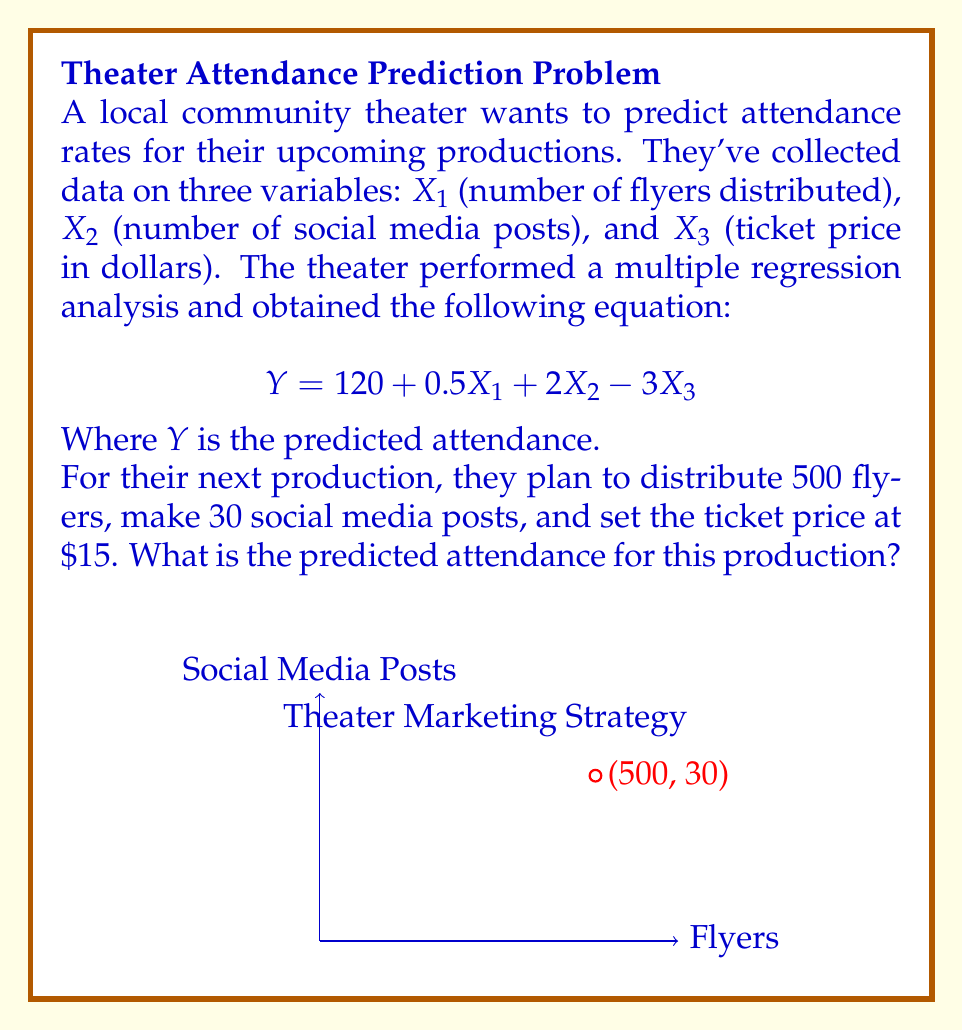Provide a solution to this math problem. To solve this problem, we'll use the multiple regression equation provided and substitute the given values for X₁, X₂, and X₃.

The equation is:
$$Y = 120 + 0.5X₁ + 2X₂ - 3X₃$$

Given:
- X₁ (number of flyers) = 500
- X₂ (number of social media posts) = 30
- X₃ (ticket price) = $15

Let's substitute these values into the equation:

$$\begin{align}
Y &= 120 + 0.5(500) + 2(30) - 3(15) \\
&= 120 + 250 + 60 - 45 \\
&= 120 + 250 + 60 - 45 \\
&= 370 + 15 \\
&= 385
\end{align}$$

Therefore, the predicted attendance for the upcoming production is 385 people.

This prediction takes into account the theater's quieter publicity tactics, focusing on flyer distribution and social media posts rather than more aggressive marketing methods, which aligns with the persona of a community theater enthusiast who appreciates subtler approaches.
Answer: 385 people 